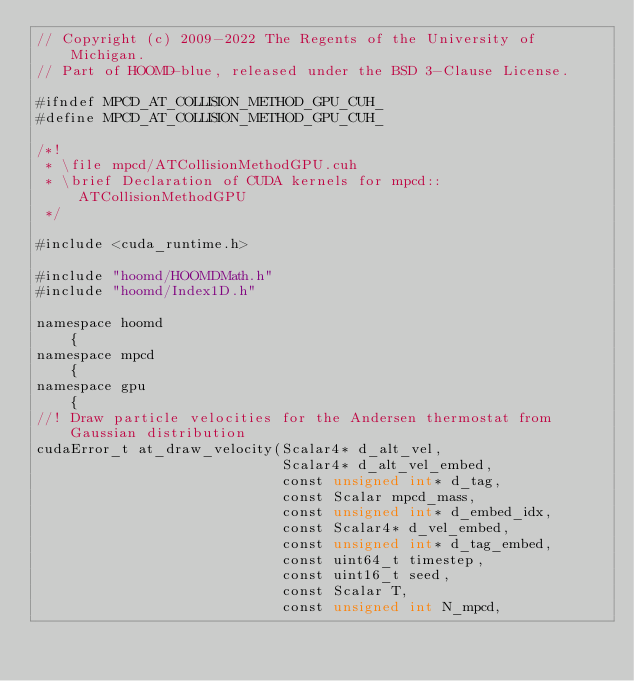<code> <loc_0><loc_0><loc_500><loc_500><_Cuda_>// Copyright (c) 2009-2022 The Regents of the University of Michigan.
// Part of HOOMD-blue, released under the BSD 3-Clause License.

#ifndef MPCD_AT_COLLISION_METHOD_GPU_CUH_
#define MPCD_AT_COLLISION_METHOD_GPU_CUH_

/*!
 * \file mpcd/ATCollisionMethodGPU.cuh
 * \brief Declaration of CUDA kernels for mpcd::ATCollisionMethodGPU
 */

#include <cuda_runtime.h>

#include "hoomd/HOOMDMath.h"
#include "hoomd/Index1D.h"

namespace hoomd
    {
namespace mpcd
    {
namespace gpu
    {
//! Draw particle velocities for the Andersen thermostat from Gaussian distribution
cudaError_t at_draw_velocity(Scalar4* d_alt_vel,
                             Scalar4* d_alt_vel_embed,
                             const unsigned int* d_tag,
                             const Scalar mpcd_mass,
                             const unsigned int* d_embed_idx,
                             const Scalar4* d_vel_embed,
                             const unsigned int* d_tag_embed,
                             const uint64_t timestep,
                             const uint16_t seed,
                             const Scalar T,
                             const unsigned int N_mpcd,</code> 